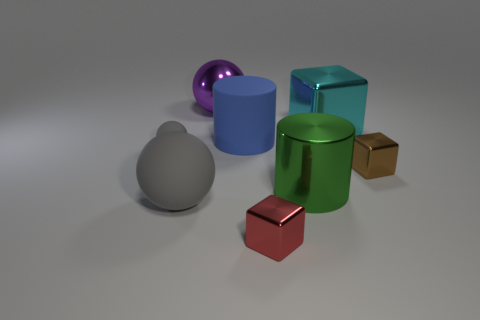Subtract all red cylinders. How many gray spheres are left? 2 Subtract all purple metal spheres. How many spheres are left? 2 Add 2 big cyan balls. How many objects exist? 10 Subtract all blocks. How many objects are left? 5 Subtract all rubber spheres. Subtract all rubber cylinders. How many objects are left? 5 Add 6 gray matte spheres. How many gray matte spheres are left? 8 Add 5 large green things. How many large green things exist? 6 Subtract 0 brown cylinders. How many objects are left? 8 Subtract all green spheres. Subtract all blue cubes. How many spheres are left? 3 